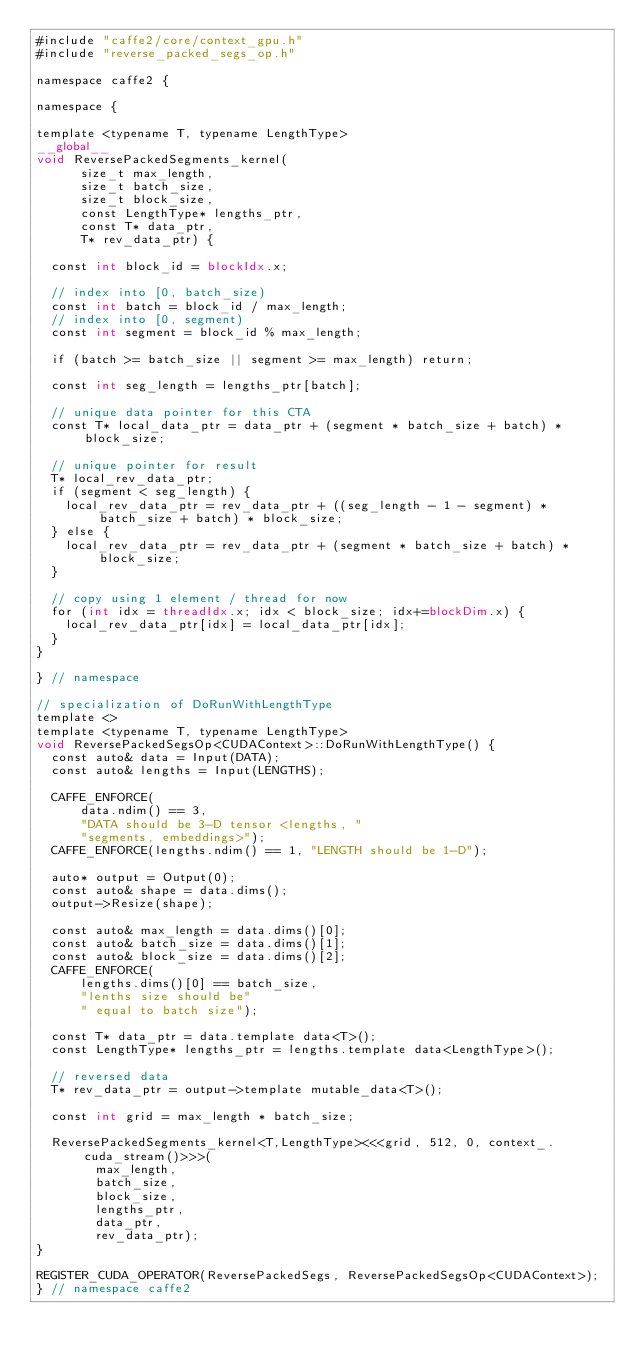<code> <loc_0><loc_0><loc_500><loc_500><_Cuda_>#include "caffe2/core/context_gpu.h"
#include "reverse_packed_segs_op.h"

namespace caffe2 {

namespace {

template <typename T, typename LengthType>
__global__
void ReversePackedSegments_kernel(
      size_t max_length,
      size_t batch_size,
      size_t block_size,
      const LengthType* lengths_ptr,
      const T* data_ptr,
      T* rev_data_ptr) {

  const int block_id = blockIdx.x;

  // index into [0, batch_size)
  const int batch = block_id / max_length;
  // index into [0, segment)
  const int segment = block_id % max_length;

  if (batch >= batch_size || segment >= max_length) return;

  const int seg_length = lengths_ptr[batch];

  // unique data pointer for this CTA
  const T* local_data_ptr = data_ptr + (segment * batch_size + batch) * block_size;

  // unique pointer for result
  T* local_rev_data_ptr;
  if (segment < seg_length) {
    local_rev_data_ptr = rev_data_ptr + ((seg_length - 1 - segment) * batch_size + batch) * block_size;
  } else {
    local_rev_data_ptr = rev_data_ptr + (segment * batch_size + batch) * block_size;
  }

  // copy using 1 element / thread for now
  for (int idx = threadIdx.x; idx < block_size; idx+=blockDim.x) {
    local_rev_data_ptr[idx] = local_data_ptr[idx];
  }
}

} // namespace

// specialization of DoRunWithLengthType
template <>
template <typename T, typename LengthType>
void ReversePackedSegsOp<CUDAContext>::DoRunWithLengthType() {
  const auto& data = Input(DATA);
  const auto& lengths = Input(LENGTHS);

  CAFFE_ENFORCE(
      data.ndim() == 3,
      "DATA should be 3-D tensor <lengths, "
      "segments, embeddings>");
  CAFFE_ENFORCE(lengths.ndim() == 1, "LENGTH should be 1-D");

  auto* output = Output(0);
  const auto& shape = data.dims();
  output->Resize(shape);

  const auto& max_length = data.dims()[0];
  const auto& batch_size = data.dims()[1];
  const auto& block_size = data.dims()[2];
  CAFFE_ENFORCE(
      lengths.dims()[0] == batch_size,
      "lenths size should be"
      " equal to batch size");

  const T* data_ptr = data.template data<T>();
  const LengthType* lengths_ptr = lengths.template data<LengthType>();

  // reversed data
  T* rev_data_ptr = output->template mutable_data<T>();

  const int grid = max_length * batch_size;

  ReversePackedSegments_kernel<T,LengthType><<<grid, 512, 0, context_.cuda_stream()>>>(
        max_length,
        batch_size,
        block_size,
        lengths_ptr,
        data_ptr,
        rev_data_ptr);
}

REGISTER_CUDA_OPERATOR(ReversePackedSegs, ReversePackedSegsOp<CUDAContext>);
} // namespace caffe2
</code> 